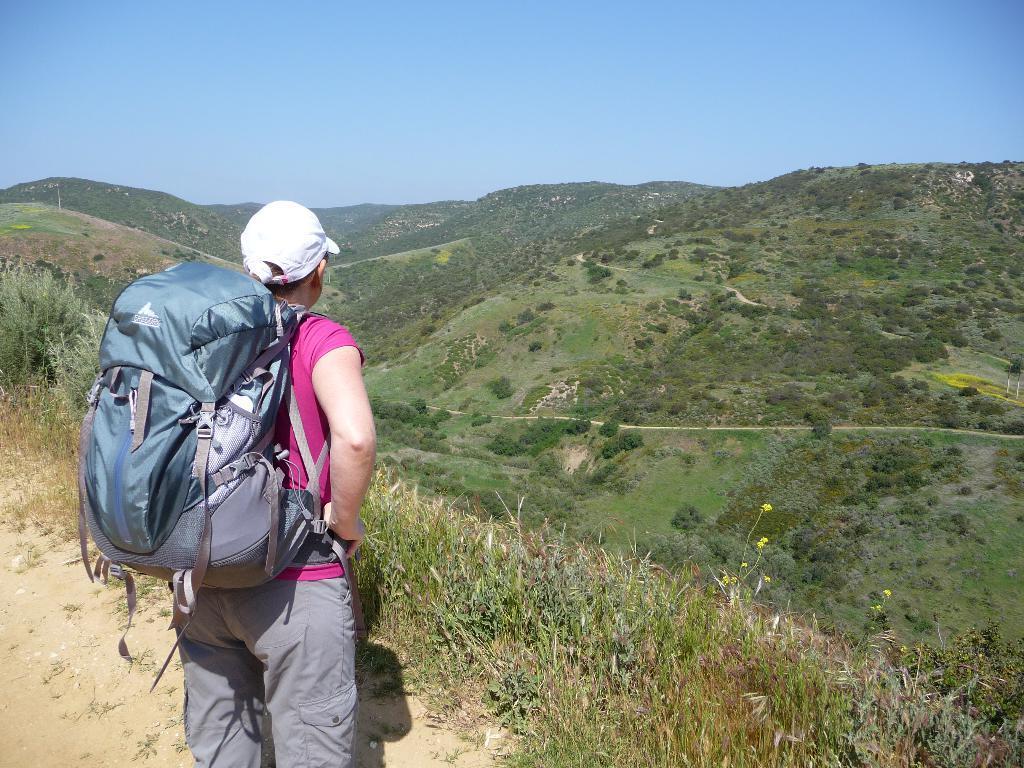Can you describe this image briefly? Here we can see a woman is standing on the ground, and at back here is the bag, and here are the mountains, and at above here is the sky. 